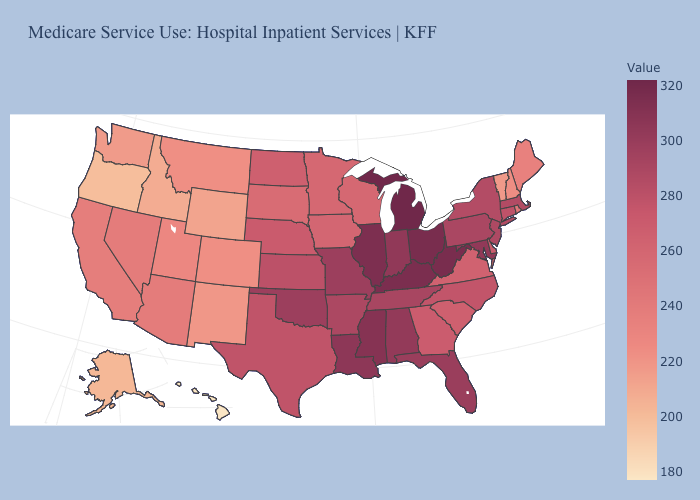Does Kansas have a higher value than Colorado?
Quick response, please. Yes. Which states have the lowest value in the South?
Answer briefly. Virginia. Does the map have missing data?
Keep it brief. No. Is the legend a continuous bar?
Write a very short answer. Yes. Which states have the highest value in the USA?
Answer briefly. Michigan. Does Washington have a lower value than Alaska?
Short answer required. No. Is the legend a continuous bar?
Answer briefly. Yes. 